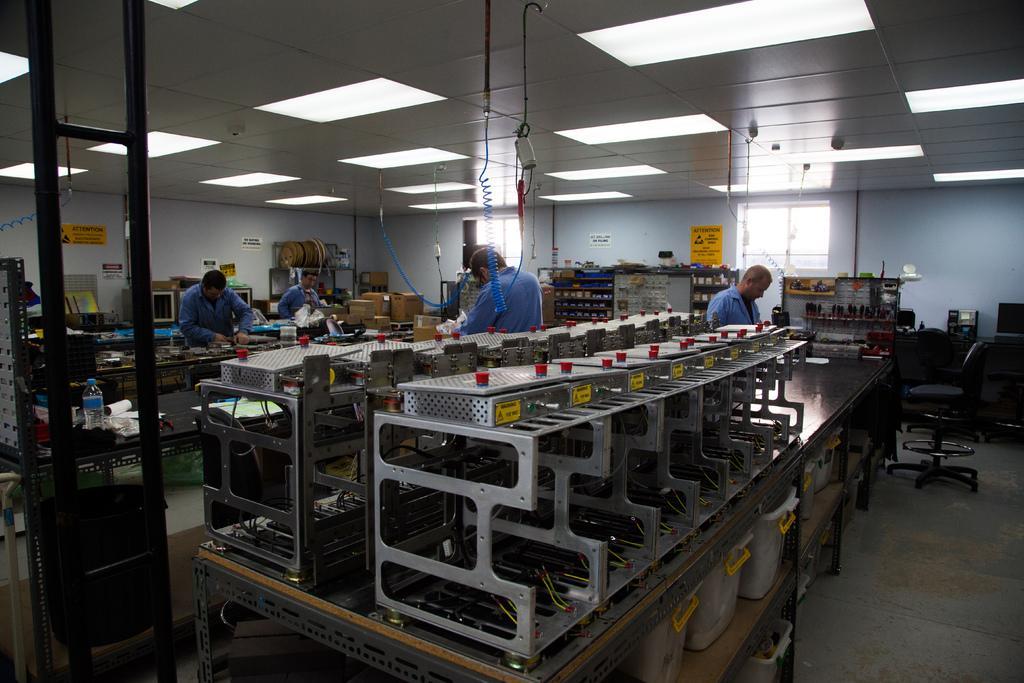Could you give a brief overview of what you see in this image? In this picture we can observe some people standing. There is a machinery in this room. We can observe windows and lights in the ceiling. In the background there is a wall. 